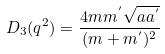Convert formula to latex. <formula><loc_0><loc_0><loc_500><loc_500>D _ { 3 } ( q ^ { 2 } ) = \frac { 4 m m ^ { ^ { \prime } } \sqrt { a a ^ { ^ { \prime } } } } { ( m + m ^ { ^ { \prime } } ) ^ { 2 } }</formula> 